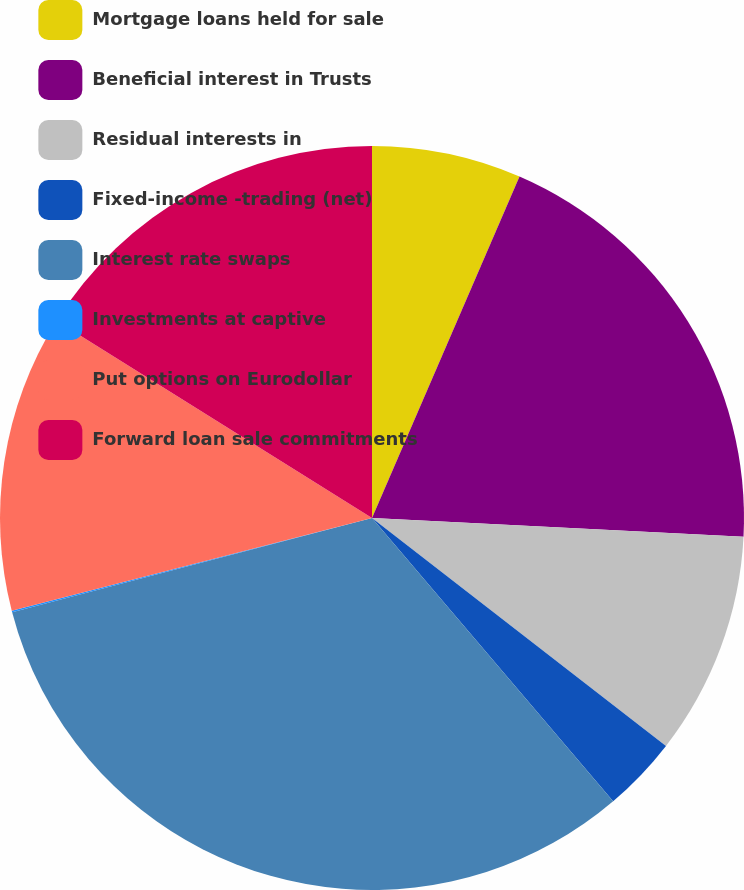Convert chart. <chart><loc_0><loc_0><loc_500><loc_500><pie_chart><fcel>Mortgage loans held for sale<fcel>Beneficial interest in Trusts<fcel>Residual interests in<fcel>Fixed-income -trading (net)<fcel>Interest rate swaps<fcel>Investments at captive<fcel>Put options on Eurodollar<fcel>Forward loan sale commitments<nl><fcel>6.49%<fcel>19.32%<fcel>9.69%<fcel>3.28%<fcel>32.15%<fcel>0.07%<fcel>12.9%<fcel>16.11%<nl></chart> 